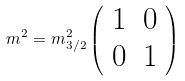Convert formula to latex. <formula><loc_0><loc_0><loc_500><loc_500>m ^ { 2 } = m ^ { 2 } _ { 3 / 2 } \left ( \begin{array} { c c } 1 & 0 \\ 0 & 1 \end{array} \right )</formula> 